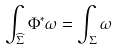Convert formula to latex. <formula><loc_0><loc_0><loc_500><loc_500>\int \nolimits _ { \widehat { \Sigma } } \Phi ^ { * } \omega = \int \nolimits _ { \Sigma } \omega</formula> 